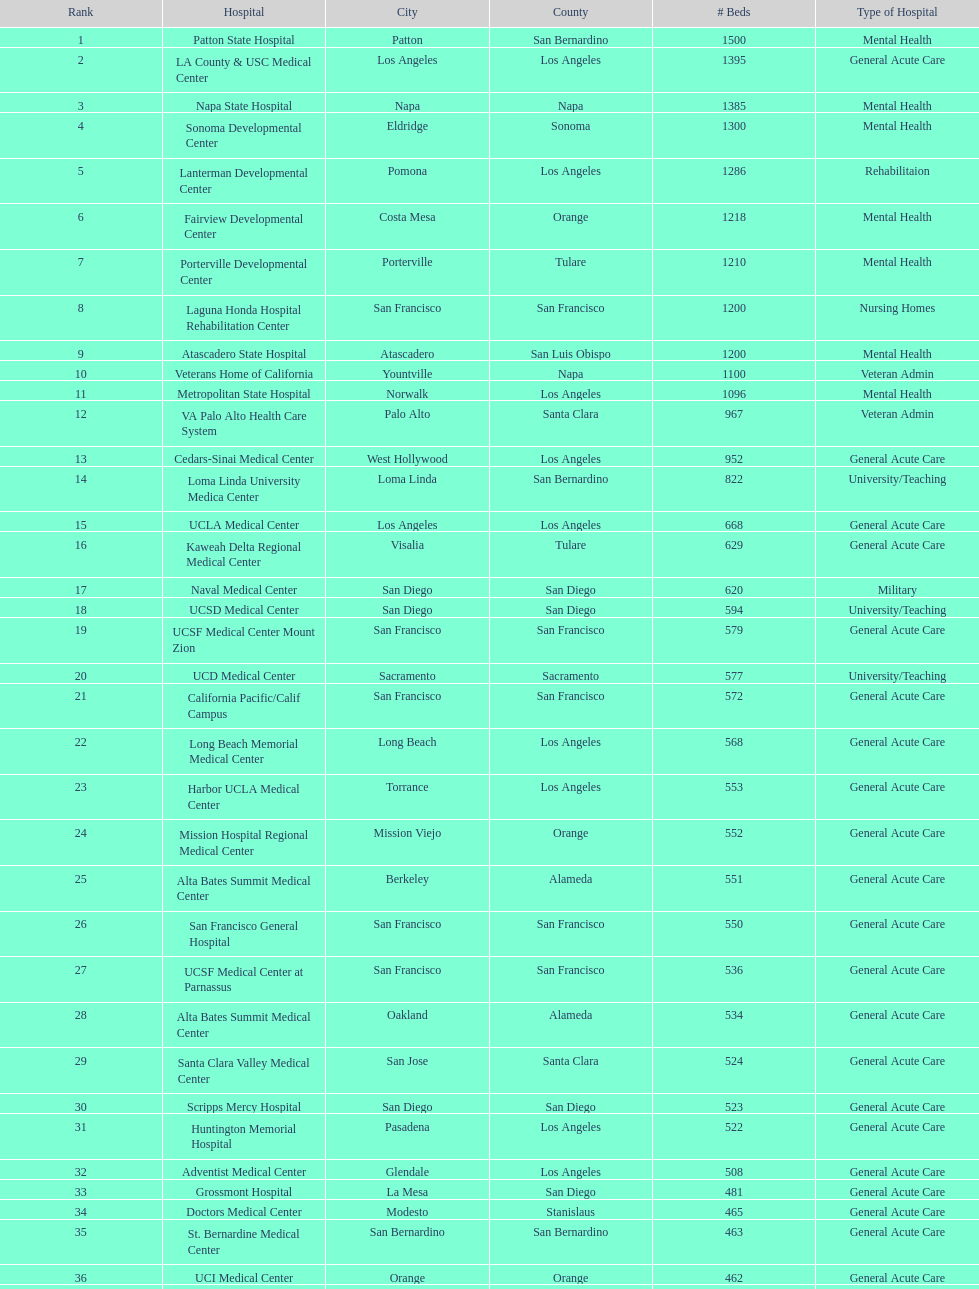How many additional general acute care hospitals are present in california compared to rehabilitation hospitals? 33. 